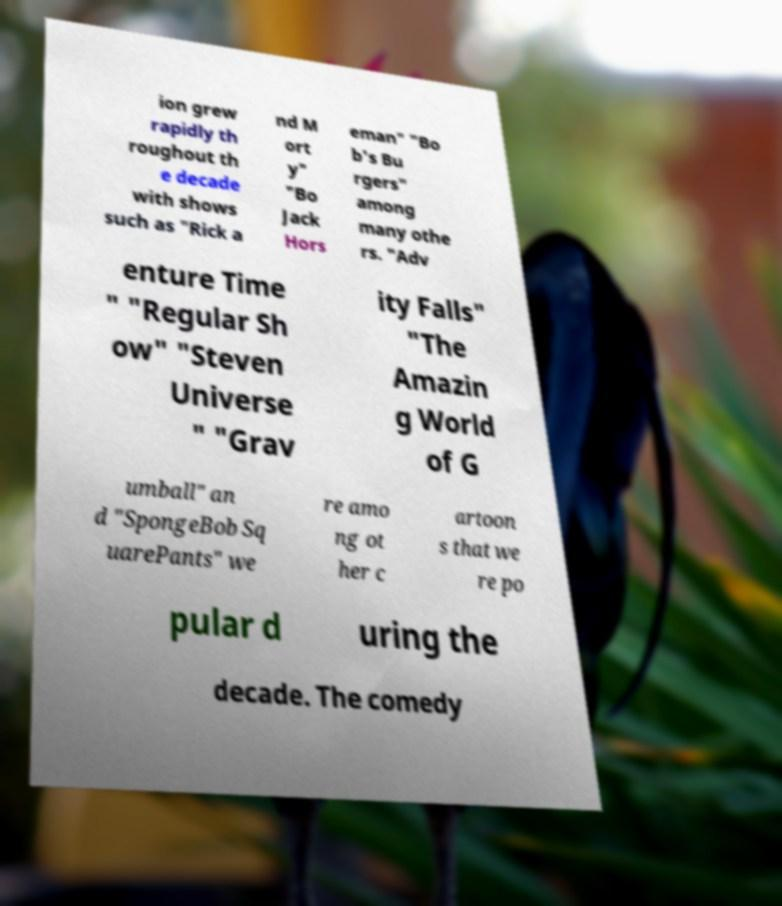Please read and relay the text visible in this image. What does it say? ion grew rapidly th roughout th e decade with shows such as "Rick a nd M ort y" "Bo Jack Hors eman" "Bo b's Bu rgers" among many othe rs. "Adv enture Time " "Regular Sh ow" "Steven Universe " "Grav ity Falls" "The Amazin g World of G umball" an d "SpongeBob Sq uarePants" we re amo ng ot her c artoon s that we re po pular d uring the decade. The comedy 